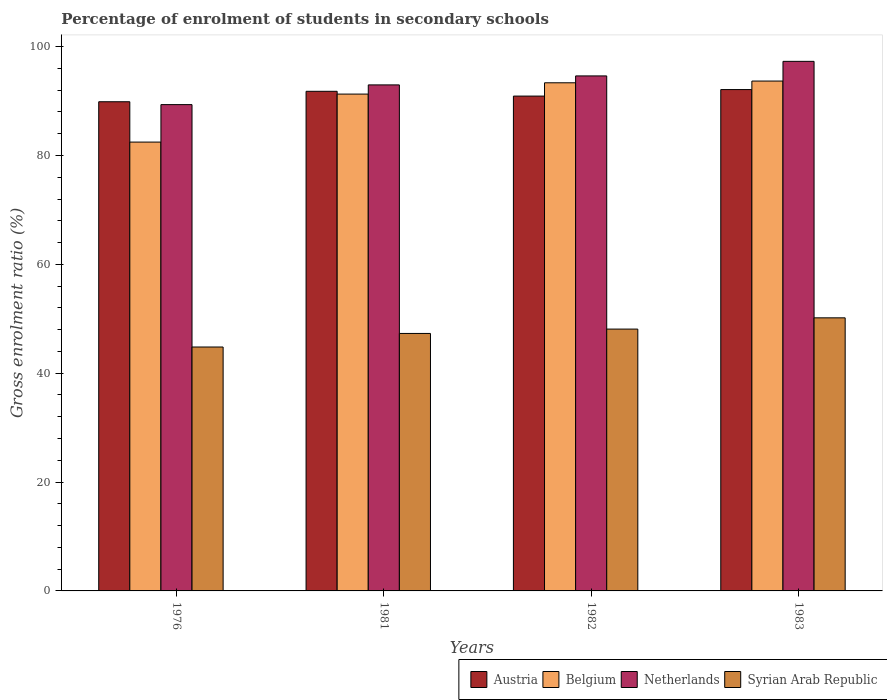How many different coloured bars are there?
Ensure brevity in your answer.  4. How many groups of bars are there?
Provide a succinct answer. 4. How many bars are there on the 3rd tick from the left?
Provide a short and direct response. 4. How many bars are there on the 2nd tick from the right?
Make the answer very short. 4. In how many cases, is the number of bars for a given year not equal to the number of legend labels?
Your response must be concise. 0. What is the percentage of students enrolled in secondary schools in Netherlands in 1983?
Keep it short and to the point. 97.3. Across all years, what is the maximum percentage of students enrolled in secondary schools in Netherlands?
Make the answer very short. 97.3. Across all years, what is the minimum percentage of students enrolled in secondary schools in Netherlands?
Your answer should be compact. 89.35. In which year was the percentage of students enrolled in secondary schools in Netherlands maximum?
Your answer should be very brief. 1983. In which year was the percentage of students enrolled in secondary schools in Netherlands minimum?
Provide a short and direct response. 1976. What is the total percentage of students enrolled in secondary schools in Belgium in the graph?
Your response must be concise. 360.8. What is the difference between the percentage of students enrolled in secondary schools in Belgium in 1982 and that in 1983?
Offer a very short reply. -0.32. What is the difference between the percentage of students enrolled in secondary schools in Netherlands in 1982 and the percentage of students enrolled in secondary schools in Syrian Arab Republic in 1983?
Your answer should be compact. 44.45. What is the average percentage of students enrolled in secondary schools in Syrian Arab Republic per year?
Give a very brief answer. 47.6. In the year 1983, what is the difference between the percentage of students enrolled in secondary schools in Belgium and percentage of students enrolled in secondary schools in Austria?
Your response must be concise. 1.57. What is the ratio of the percentage of students enrolled in secondary schools in Belgium in 1976 to that in 1983?
Your response must be concise. 0.88. Is the percentage of students enrolled in secondary schools in Netherlands in 1981 less than that in 1983?
Your response must be concise. Yes. What is the difference between the highest and the second highest percentage of students enrolled in secondary schools in Austria?
Your answer should be very brief. 0.32. What is the difference between the highest and the lowest percentage of students enrolled in secondary schools in Syrian Arab Republic?
Ensure brevity in your answer.  5.36. In how many years, is the percentage of students enrolled in secondary schools in Austria greater than the average percentage of students enrolled in secondary schools in Austria taken over all years?
Your answer should be compact. 2. Is the sum of the percentage of students enrolled in secondary schools in Austria in 1976 and 1981 greater than the maximum percentage of students enrolled in secondary schools in Netherlands across all years?
Offer a very short reply. Yes. Is it the case that in every year, the sum of the percentage of students enrolled in secondary schools in Netherlands and percentage of students enrolled in secondary schools in Austria is greater than the sum of percentage of students enrolled in secondary schools in Syrian Arab Republic and percentage of students enrolled in secondary schools in Belgium?
Provide a short and direct response. No. What does the 3rd bar from the left in 1981 represents?
Ensure brevity in your answer.  Netherlands. Are all the bars in the graph horizontal?
Ensure brevity in your answer.  No. How many years are there in the graph?
Your response must be concise. 4. What is the difference between two consecutive major ticks on the Y-axis?
Ensure brevity in your answer.  20. Does the graph contain grids?
Your answer should be very brief. No. What is the title of the graph?
Offer a very short reply. Percentage of enrolment of students in secondary schools. What is the label or title of the Y-axis?
Your response must be concise. Gross enrolment ratio (%). What is the Gross enrolment ratio (%) of Austria in 1976?
Provide a succinct answer. 89.88. What is the Gross enrolment ratio (%) in Belgium in 1976?
Your answer should be very brief. 82.47. What is the Gross enrolment ratio (%) in Netherlands in 1976?
Your answer should be compact. 89.35. What is the Gross enrolment ratio (%) of Syrian Arab Republic in 1976?
Your response must be concise. 44.82. What is the Gross enrolment ratio (%) of Austria in 1981?
Your response must be concise. 91.8. What is the Gross enrolment ratio (%) of Belgium in 1981?
Make the answer very short. 91.29. What is the Gross enrolment ratio (%) in Netherlands in 1981?
Provide a succinct answer. 92.97. What is the Gross enrolment ratio (%) in Syrian Arab Republic in 1981?
Provide a short and direct response. 47.31. What is the Gross enrolment ratio (%) in Austria in 1982?
Your response must be concise. 90.92. What is the Gross enrolment ratio (%) of Belgium in 1982?
Your response must be concise. 93.36. What is the Gross enrolment ratio (%) in Netherlands in 1982?
Give a very brief answer. 94.62. What is the Gross enrolment ratio (%) in Syrian Arab Republic in 1982?
Your response must be concise. 48.11. What is the Gross enrolment ratio (%) in Austria in 1983?
Your answer should be very brief. 92.12. What is the Gross enrolment ratio (%) of Belgium in 1983?
Keep it short and to the point. 93.68. What is the Gross enrolment ratio (%) in Netherlands in 1983?
Provide a succinct answer. 97.3. What is the Gross enrolment ratio (%) of Syrian Arab Republic in 1983?
Your answer should be compact. 50.17. Across all years, what is the maximum Gross enrolment ratio (%) of Austria?
Ensure brevity in your answer.  92.12. Across all years, what is the maximum Gross enrolment ratio (%) of Belgium?
Your response must be concise. 93.68. Across all years, what is the maximum Gross enrolment ratio (%) of Netherlands?
Your response must be concise. 97.3. Across all years, what is the maximum Gross enrolment ratio (%) of Syrian Arab Republic?
Your response must be concise. 50.17. Across all years, what is the minimum Gross enrolment ratio (%) in Austria?
Provide a succinct answer. 89.88. Across all years, what is the minimum Gross enrolment ratio (%) in Belgium?
Your answer should be compact. 82.47. Across all years, what is the minimum Gross enrolment ratio (%) of Netherlands?
Your answer should be compact. 89.35. Across all years, what is the minimum Gross enrolment ratio (%) of Syrian Arab Republic?
Your answer should be very brief. 44.82. What is the total Gross enrolment ratio (%) in Austria in the graph?
Make the answer very short. 364.71. What is the total Gross enrolment ratio (%) of Belgium in the graph?
Provide a short and direct response. 360.8. What is the total Gross enrolment ratio (%) of Netherlands in the graph?
Your answer should be compact. 374.25. What is the total Gross enrolment ratio (%) in Syrian Arab Republic in the graph?
Give a very brief answer. 190.41. What is the difference between the Gross enrolment ratio (%) in Austria in 1976 and that in 1981?
Ensure brevity in your answer.  -1.92. What is the difference between the Gross enrolment ratio (%) of Belgium in 1976 and that in 1981?
Your answer should be very brief. -8.82. What is the difference between the Gross enrolment ratio (%) of Netherlands in 1976 and that in 1981?
Ensure brevity in your answer.  -3.62. What is the difference between the Gross enrolment ratio (%) of Syrian Arab Republic in 1976 and that in 1981?
Your answer should be compact. -2.49. What is the difference between the Gross enrolment ratio (%) of Austria in 1976 and that in 1982?
Provide a succinct answer. -1.04. What is the difference between the Gross enrolment ratio (%) of Belgium in 1976 and that in 1982?
Provide a succinct answer. -10.89. What is the difference between the Gross enrolment ratio (%) of Netherlands in 1976 and that in 1982?
Your response must be concise. -5.27. What is the difference between the Gross enrolment ratio (%) in Syrian Arab Republic in 1976 and that in 1982?
Your response must be concise. -3.29. What is the difference between the Gross enrolment ratio (%) in Austria in 1976 and that in 1983?
Make the answer very short. -2.24. What is the difference between the Gross enrolment ratio (%) of Belgium in 1976 and that in 1983?
Give a very brief answer. -11.21. What is the difference between the Gross enrolment ratio (%) in Netherlands in 1976 and that in 1983?
Your response must be concise. -7.95. What is the difference between the Gross enrolment ratio (%) in Syrian Arab Republic in 1976 and that in 1983?
Give a very brief answer. -5.36. What is the difference between the Gross enrolment ratio (%) of Austria in 1981 and that in 1982?
Provide a short and direct response. 0.88. What is the difference between the Gross enrolment ratio (%) of Belgium in 1981 and that in 1982?
Provide a short and direct response. -2.07. What is the difference between the Gross enrolment ratio (%) of Netherlands in 1981 and that in 1982?
Offer a terse response. -1.65. What is the difference between the Gross enrolment ratio (%) in Syrian Arab Republic in 1981 and that in 1982?
Your response must be concise. -0.8. What is the difference between the Gross enrolment ratio (%) of Austria in 1981 and that in 1983?
Provide a succinct answer. -0.32. What is the difference between the Gross enrolment ratio (%) of Belgium in 1981 and that in 1983?
Keep it short and to the point. -2.39. What is the difference between the Gross enrolment ratio (%) in Netherlands in 1981 and that in 1983?
Give a very brief answer. -4.33. What is the difference between the Gross enrolment ratio (%) in Syrian Arab Republic in 1981 and that in 1983?
Ensure brevity in your answer.  -2.87. What is the difference between the Gross enrolment ratio (%) of Austria in 1982 and that in 1983?
Make the answer very short. -1.2. What is the difference between the Gross enrolment ratio (%) of Belgium in 1982 and that in 1983?
Provide a succinct answer. -0.32. What is the difference between the Gross enrolment ratio (%) in Netherlands in 1982 and that in 1983?
Make the answer very short. -2.68. What is the difference between the Gross enrolment ratio (%) in Syrian Arab Republic in 1982 and that in 1983?
Your response must be concise. -2.07. What is the difference between the Gross enrolment ratio (%) in Austria in 1976 and the Gross enrolment ratio (%) in Belgium in 1981?
Give a very brief answer. -1.41. What is the difference between the Gross enrolment ratio (%) in Austria in 1976 and the Gross enrolment ratio (%) in Netherlands in 1981?
Give a very brief answer. -3.1. What is the difference between the Gross enrolment ratio (%) of Austria in 1976 and the Gross enrolment ratio (%) of Syrian Arab Republic in 1981?
Give a very brief answer. 42.57. What is the difference between the Gross enrolment ratio (%) in Belgium in 1976 and the Gross enrolment ratio (%) in Netherlands in 1981?
Your answer should be compact. -10.51. What is the difference between the Gross enrolment ratio (%) in Belgium in 1976 and the Gross enrolment ratio (%) in Syrian Arab Republic in 1981?
Offer a very short reply. 35.16. What is the difference between the Gross enrolment ratio (%) in Netherlands in 1976 and the Gross enrolment ratio (%) in Syrian Arab Republic in 1981?
Provide a short and direct response. 42.04. What is the difference between the Gross enrolment ratio (%) in Austria in 1976 and the Gross enrolment ratio (%) in Belgium in 1982?
Make the answer very short. -3.48. What is the difference between the Gross enrolment ratio (%) in Austria in 1976 and the Gross enrolment ratio (%) in Netherlands in 1982?
Your answer should be very brief. -4.75. What is the difference between the Gross enrolment ratio (%) in Austria in 1976 and the Gross enrolment ratio (%) in Syrian Arab Republic in 1982?
Your answer should be compact. 41.77. What is the difference between the Gross enrolment ratio (%) in Belgium in 1976 and the Gross enrolment ratio (%) in Netherlands in 1982?
Offer a very short reply. -12.16. What is the difference between the Gross enrolment ratio (%) in Belgium in 1976 and the Gross enrolment ratio (%) in Syrian Arab Republic in 1982?
Provide a succinct answer. 34.36. What is the difference between the Gross enrolment ratio (%) in Netherlands in 1976 and the Gross enrolment ratio (%) in Syrian Arab Republic in 1982?
Make the answer very short. 41.24. What is the difference between the Gross enrolment ratio (%) in Austria in 1976 and the Gross enrolment ratio (%) in Belgium in 1983?
Give a very brief answer. -3.8. What is the difference between the Gross enrolment ratio (%) of Austria in 1976 and the Gross enrolment ratio (%) of Netherlands in 1983?
Your response must be concise. -7.42. What is the difference between the Gross enrolment ratio (%) in Austria in 1976 and the Gross enrolment ratio (%) in Syrian Arab Republic in 1983?
Keep it short and to the point. 39.7. What is the difference between the Gross enrolment ratio (%) of Belgium in 1976 and the Gross enrolment ratio (%) of Netherlands in 1983?
Your response must be concise. -14.83. What is the difference between the Gross enrolment ratio (%) in Belgium in 1976 and the Gross enrolment ratio (%) in Syrian Arab Republic in 1983?
Your answer should be very brief. 32.29. What is the difference between the Gross enrolment ratio (%) of Netherlands in 1976 and the Gross enrolment ratio (%) of Syrian Arab Republic in 1983?
Ensure brevity in your answer.  39.18. What is the difference between the Gross enrolment ratio (%) of Austria in 1981 and the Gross enrolment ratio (%) of Belgium in 1982?
Your answer should be very brief. -1.57. What is the difference between the Gross enrolment ratio (%) in Austria in 1981 and the Gross enrolment ratio (%) in Netherlands in 1982?
Your answer should be compact. -2.83. What is the difference between the Gross enrolment ratio (%) of Austria in 1981 and the Gross enrolment ratio (%) of Syrian Arab Republic in 1982?
Your response must be concise. 43.69. What is the difference between the Gross enrolment ratio (%) in Belgium in 1981 and the Gross enrolment ratio (%) in Netherlands in 1982?
Offer a terse response. -3.34. What is the difference between the Gross enrolment ratio (%) of Belgium in 1981 and the Gross enrolment ratio (%) of Syrian Arab Republic in 1982?
Ensure brevity in your answer.  43.18. What is the difference between the Gross enrolment ratio (%) in Netherlands in 1981 and the Gross enrolment ratio (%) in Syrian Arab Republic in 1982?
Your answer should be very brief. 44.87. What is the difference between the Gross enrolment ratio (%) of Austria in 1981 and the Gross enrolment ratio (%) of Belgium in 1983?
Provide a short and direct response. -1.88. What is the difference between the Gross enrolment ratio (%) of Austria in 1981 and the Gross enrolment ratio (%) of Netherlands in 1983?
Your answer should be compact. -5.5. What is the difference between the Gross enrolment ratio (%) of Austria in 1981 and the Gross enrolment ratio (%) of Syrian Arab Republic in 1983?
Provide a succinct answer. 41.62. What is the difference between the Gross enrolment ratio (%) of Belgium in 1981 and the Gross enrolment ratio (%) of Netherlands in 1983?
Your response must be concise. -6.01. What is the difference between the Gross enrolment ratio (%) in Belgium in 1981 and the Gross enrolment ratio (%) in Syrian Arab Republic in 1983?
Your response must be concise. 41.11. What is the difference between the Gross enrolment ratio (%) in Netherlands in 1981 and the Gross enrolment ratio (%) in Syrian Arab Republic in 1983?
Ensure brevity in your answer.  42.8. What is the difference between the Gross enrolment ratio (%) in Austria in 1982 and the Gross enrolment ratio (%) in Belgium in 1983?
Offer a very short reply. -2.76. What is the difference between the Gross enrolment ratio (%) in Austria in 1982 and the Gross enrolment ratio (%) in Netherlands in 1983?
Provide a short and direct response. -6.38. What is the difference between the Gross enrolment ratio (%) of Austria in 1982 and the Gross enrolment ratio (%) of Syrian Arab Republic in 1983?
Your response must be concise. 40.75. What is the difference between the Gross enrolment ratio (%) of Belgium in 1982 and the Gross enrolment ratio (%) of Netherlands in 1983?
Your answer should be very brief. -3.94. What is the difference between the Gross enrolment ratio (%) of Belgium in 1982 and the Gross enrolment ratio (%) of Syrian Arab Republic in 1983?
Your answer should be compact. 43.19. What is the difference between the Gross enrolment ratio (%) in Netherlands in 1982 and the Gross enrolment ratio (%) in Syrian Arab Republic in 1983?
Provide a succinct answer. 44.45. What is the average Gross enrolment ratio (%) of Austria per year?
Provide a succinct answer. 91.18. What is the average Gross enrolment ratio (%) of Belgium per year?
Provide a short and direct response. 90.2. What is the average Gross enrolment ratio (%) of Netherlands per year?
Offer a terse response. 93.56. What is the average Gross enrolment ratio (%) of Syrian Arab Republic per year?
Your response must be concise. 47.6. In the year 1976, what is the difference between the Gross enrolment ratio (%) of Austria and Gross enrolment ratio (%) of Belgium?
Your answer should be compact. 7.41. In the year 1976, what is the difference between the Gross enrolment ratio (%) in Austria and Gross enrolment ratio (%) in Netherlands?
Ensure brevity in your answer.  0.53. In the year 1976, what is the difference between the Gross enrolment ratio (%) of Austria and Gross enrolment ratio (%) of Syrian Arab Republic?
Your response must be concise. 45.06. In the year 1976, what is the difference between the Gross enrolment ratio (%) of Belgium and Gross enrolment ratio (%) of Netherlands?
Give a very brief answer. -6.88. In the year 1976, what is the difference between the Gross enrolment ratio (%) in Belgium and Gross enrolment ratio (%) in Syrian Arab Republic?
Make the answer very short. 37.65. In the year 1976, what is the difference between the Gross enrolment ratio (%) of Netherlands and Gross enrolment ratio (%) of Syrian Arab Republic?
Offer a very short reply. 44.54. In the year 1981, what is the difference between the Gross enrolment ratio (%) of Austria and Gross enrolment ratio (%) of Belgium?
Offer a very short reply. 0.51. In the year 1981, what is the difference between the Gross enrolment ratio (%) of Austria and Gross enrolment ratio (%) of Netherlands?
Ensure brevity in your answer.  -1.18. In the year 1981, what is the difference between the Gross enrolment ratio (%) in Austria and Gross enrolment ratio (%) in Syrian Arab Republic?
Your answer should be very brief. 44.49. In the year 1981, what is the difference between the Gross enrolment ratio (%) in Belgium and Gross enrolment ratio (%) in Netherlands?
Your response must be concise. -1.69. In the year 1981, what is the difference between the Gross enrolment ratio (%) of Belgium and Gross enrolment ratio (%) of Syrian Arab Republic?
Your answer should be compact. 43.98. In the year 1981, what is the difference between the Gross enrolment ratio (%) of Netherlands and Gross enrolment ratio (%) of Syrian Arab Republic?
Your answer should be very brief. 45.67. In the year 1982, what is the difference between the Gross enrolment ratio (%) of Austria and Gross enrolment ratio (%) of Belgium?
Keep it short and to the point. -2.44. In the year 1982, what is the difference between the Gross enrolment ratio (%) of Austria and Gross enrolment ratio (%) of Netherlands?
Offer a terse response. -3.7. In the year 1982, what is the difference between the Gross enrolment ratio (%) in Austria and Gross enrolment ratio (%) in Syrian Arab Republic?
Your answer should be very brief. 42.81. In the year 1982, what is the difference between the Gross enrolment ratio (%) in Belgium and Gross enrolment ratio (%) in Netherlands?
Your answer should be compact. -1.26. In the year 1982, what is the difference between the Gross enrolment ratio (%) of Belgium and Gross enrolment ratio (%) of Syrian Arab Republic?
Make the answer very short. 45.26. In the year 1982, what is the difference between the Gross enrolment ratio (%) of Netherlands and Gross enrolment ratio (%) of Syrian Arab Republic?
Your response must be concise. 46.52. In the year 1983, what is the difference between the Gross enrolment ratio (%) in Austria and Gross enrolment ratio (%) in Belgium?
Give a very brief answer. -1.56. In the year 1983, what is the difference between the Gross enrolment ratio (%) in Austria and Gross enrolment ratio (%) in Netherlands?
Provide a short and direct response. -5.18. In the year 1983, what is the difference between the Gross enrolment ratio (%) in Austria and Gross enrolment ratio (%) in Syrian Arab Republic?
Make the answer very short. 41.94. In the year 1983, what is the difference between the Gross enrolment ratio (%) of Belgium and Gross enrolment ratio (%) of Netherlands?
Provide a succinct answer. -3.62. In the year 1983, what is the difference between the Gross enrolment ratio (%) in Belgium and Gross enrolment ratio (%) in Syrian Arab Republic?
Provide a short and direct response. 43.51. In the year 1983, what is the difference between the Gross enrolment ratio (%) in Netherlands and Gross enrolment ratio (%) in Syrian Arab Republic?
Your answer should be compact. 47.13. What is the ratio of the Gross enrolment ratio (%) in Austria in 1976 to that in 1981?
Offer a terse response. 0.98. What is the ratio of the Gross enrolment ratio (%) of Belgium in 1976 to that in 1981?
Ensure brevity in your answer.  0.9. What is the ratio of the Gross enrolment ratio (%) in Syrian Arab Republic in 1976 to that in 1981?
Provide a short and direct response. 0.95. What is the ratio of the Gross enrolment ratio (%) in Belgium in 1976 to that in 1982?
Offer a terse response. 0.88. What is the ratio of the Gross enrolment ratio (%) in Netherlands in 1976 to that in 1982?
Your response must be concise. 0.94. What is the ratio of the Gross enrolment ratio (%) of Syrian Arab Republic in 1976 to that in 1982?
Provide a succinct answer. 0.93. What is the ratio of the Gross enrolment ratio (%) in Austria in 1976 to that in 1983?
Offer a very short reply. 0.98. What is the ratio of the Gross enrolment ratio (%) in Belgium in 1976 to that in 1983?
Give a very brief answer. 0.88. What is the ratio of the Gross enrolment ratio (%) in Netherlands in 1976 to that in 1983?
Ensure brevity in your answer.  0.92. What is the ratio of the Gross enrolment ratio (%) of Syrian Arab Republic in 1976 to that in 1983?
Make the answer very short. 0.89. What is the ratio of the Gross enrolment ratio (%) in Austria in 1981 to that in 1982?
Your answer should be very brief. 1.01. What is the ratio of the Gross enrolment ratio (%) of Belgium in 1981 to that in 1982?
Your answer should be compact. 0.98. What is the ratio of the Gross enrolment ratio (%) in Netherlands in 1981 to that in 1982?
Your response must be concise. 0.98. What is the ratio of the Gross enrolment ratio (%) in Syrian Arab Republic in 1981 to that in 1982?
Your answer should be very brief. 0.98. What is the ratio of the Gross enrolment ratio (%) in Belgium in 1981 to that in 1983?
Your answer should be very brief. 0.97. What is the ratio of the Gross enrolment ratio (%) of Netherlands in 1981 to that in 1983?
Provide a short and direct response. 0.96. What is the ratio of the Gross enrolment ratio (%) in Syrian Arab Republic in 1981 to that in 1983?
Give a very brief answer. 0.94. What is the ratio of the Gross enrolment ratio (%) in Austria in 1982 to that in 1983?
Your answer should be compact. 0.99. What is the ratio of the Gross enrolment ratio (%) of Netherlands in 1982 to that in 1983?
Give a very brief answer. 0.97. What is the ratio of the Gross enrolment ratio (%) in Syrian Arab Republic in 1982 to that in 1983?
Provide a succinct answer. 0.96. What is the difference between the highest and the second highest Gross enrolment ratio (%) of Austria?
Ensure brevity in your answer.  0.32. What is the difference between the highest and the second highest Gross enrolment ratio (%) in Belgium?
Ensure brevity in your answer.  0.32. What is the difference between the highest and the second highest Gross enrolment ratio (%) in Netherlands?
Provide a succinct answer. 2.68. What is the difference between the highest and the second highest Gross enrolment ratio (%) in Syrian Arab Republic?
Keep it short and to the point. 2.07. What is the difference between the highest and the lowest Gross enrolment ratio (%) in Austria?
Your response must be concise. 2.24. What is the difference between the highest and the lowest Gross enrolment ratio (%) of Belgium?
Provide a succinct answer. 11.21. What is the difference between the highest and the lowest Gross enrolment ratio (%) in Netherlands?
Provide a succinct answer. 7.95. What is the difference between the highest and the lowest Gross enrolment ratio (%) of Syrian Arab Republic?
Make the answer very short. 5.36. 